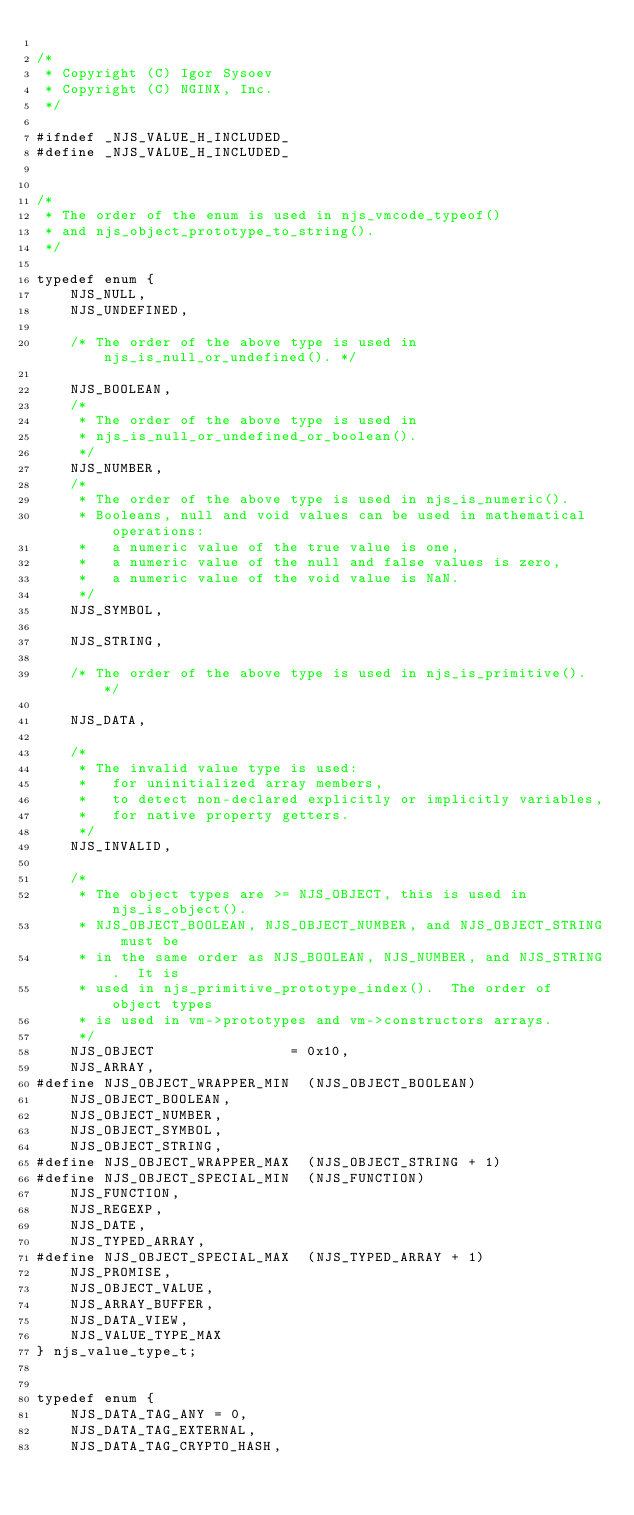Convert code to text. <code><loc_0><loc_0><loc_500><loc_500><_C_>
/*
 * Copyright (C) Igor Sysoev
 * Copyright (C) NGINX, Inc.
 */

#ifndef _NJS_VALUE_H_INCLUDED_
#define _NJS_VALUE_H_INCLUDED_


/*
 * The order of the enum is used in njs_vmcode_typeof()
 * and njs_object_prototype_to_string().
 */

typedef enum {
    NJS_NULL,
    NJS_UNDEFINED,

    /* The order of the above type is used in njs_is_null_or_undefined(). */

    NJS_BOOLEAN,
    /*
     * The order of the above type is used in
     * njs_is_null_or_undefined_or_boolean().
     */
    NJS_NUMBER,
    /*
     * The order of the above type is used in njs_is_numeric().
     * Booleans, null and void values can be used in mathematical operations:
     *   a numeric value of the true value is one,
     *   a numeric value of the null and false values is zero,
     *   a numeric value of the void value is NaN.
     */
    NJS_SYMBOL,

    NJS_STRING,

    /* The order of the above type is used in njs_is_primitive(). */

    NJS_DATA,

    /*
     * The invalid value type is used:
     *   for uninitialized array members,
     *   to detect non-declared explicitly or implicitly variables,
     *   for native property getters.
     */
    NJS_INVALID,

    /*
     * The object types are >= NJS_OBJECT, this is used in njs_is_object().
     * NJS_OBJECT_BOOLEAN, NJS_OBJECT_NUMBER, and NJS_OBJECT_STRING must be
     * in the same order as NJS_BOOLEAN, NJS_NUMBER, and NJS_STRING.  It is
     * used in njs_primitive_prototype_index().  The order of object types
     * is used in vm->prototypes and vm->constructors arrays.
     */
    NJS_OBJECT                = 0x10,
    NJS_ARRAY,
#define NJS_OBJECT_WRAPPER_MIN  (NJS_OBJECT_BOOLEAN)
    NJS_OBJECT_BOOLEAN,
    NJS_OBJECT_NUMBER,
    NJS_OBJECT_SYMBOL,
    NJS_OBJECT_STRING,
#define NJS_OBJECT_WRAPPER_MAX  (NJS_OBJECT_STRING + 1)
#define NJS_OBJECT_SPECIAL_MIN  (NJS_FUNCTION)
    NJS_FUNCTION,
    NJS_REGEXP,
    NJS_DATE,
    NJS_TYPED_ARRAY,
#define NJS_OBJECT_SPECIAL_MAX  (NJS_TYPED_ARRAY + 1)
    NJS_PROMISE,
    NJS_OBJECT_VALUE,
    NJS_ARRAY_BUFFER,
    NJS_DATA_VIEW,
    NJS_VALUE_TYPE_MAX
} njs_value_type_t;


typedef enum {
    NJS_DATA_TAG_ANY = 0,
    NJS_DATA_TAG_EXTERNAL,
    NJS_DATA_TAG_CRYPTO_HASH,</code> 